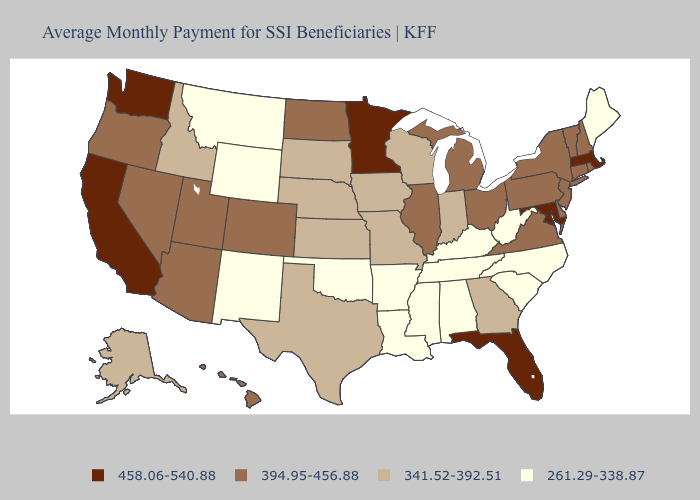Does Texas have the lowest value in the USA?
Write a very short answer. No. Among the states that border Tennessee , which have the highest value?
Be succinct. Virginia. Among the states that border Connecticut , which have the lowest value?
Write a very short answer. New York, Rhode Island. What is the highest value in the USA?
Be succinct. 458.06-540.88. Is the legend a continuous bar?
Give a very brief answer. No. What is the value of Delaware?
Answer briefly. 394.95-456.88. What is the value of Texas?
Give a very brief answer. 341.52-392.51. What is the value of Arizona?
Write a very short answer. 394.95-456.88. Is the legend a continuous bar?
Write a very short answer. No. Does the first symbol in the legend represent the smallest category?
Short answer required. No. Name the states that have a value in the range 458.06-540.88?
Short answer required. California, Florida, Maryland, Massachusetts, Minnesota, Washington. Name the states that have a value in the range 261.29-338.87?
Short answer required. Alabama, Arkansas, Kentucky, Louisiana, Maine, Mississippi, Montana, New Mexico, North Carolina, Oklahoma, South Carolina, Tennessee, West Virginia, Wyoming. Name the states that have a value in the range 394.95-456.88?
Write a very short answer. Arizona, Colorado, Connecticut, Delaware, Hawaii, Illinois, Michigan, Nevada, New Hampshire, New Jersey, New York, North Dakota, Ohio, Oregon, Pennsylvania, Rhode Island, Utah, Vermont, Virginia. Name the states that have a value in the range 458.06-540.88?
Keep it brief. California, Florida, Maryland, Massachusetts, Minnesota, Washington. 